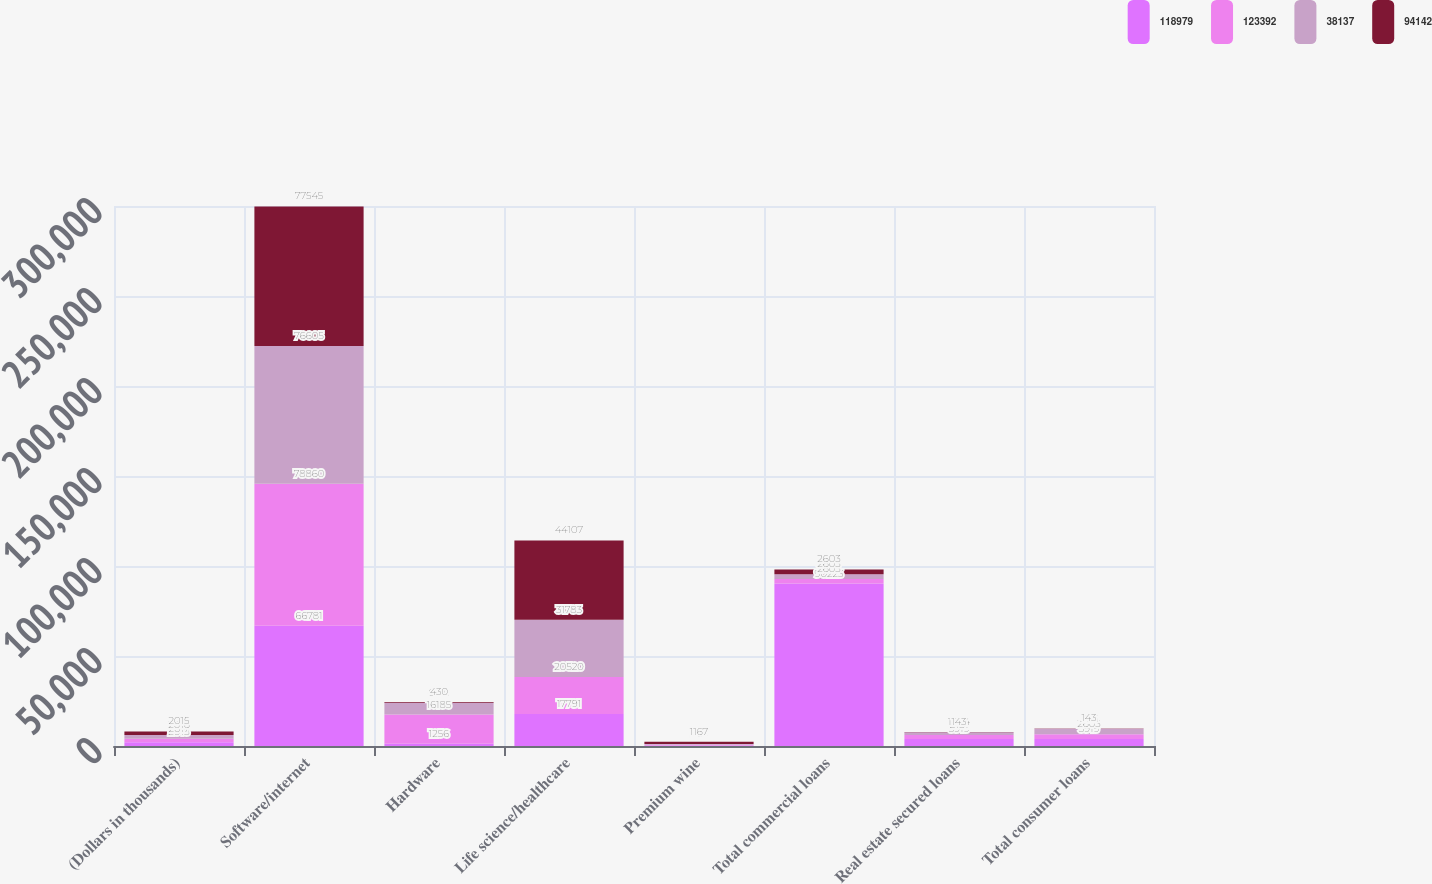Convert chart. <chart><loc_0><loc_0><loc_500><loc_500><stacked_bar_chart><ecel><fcel>(Dollars in thousands)<fcel>Software/internet<fcel>Hardware<fcel>Life science/healthcare<fcel>Premium wine<fcel>Total commercial loans<fcel>Real estate secured loans<fcel>Total consumer loans<nl><fcel>118979<fcel>2018<fcel>66781<fcel>1256<fcel>17791<fcel>284<fcel>90223<fcel>3919<fcel>3919<nl><fcel>123392<fcel>2017<fcel>78860<fcel>16185<fcel>20520<fcel>401<fcel>2603<fcel>2181<fcel>2603<nl><fcel>38137<fcel>2016<fcel>76605<fcel>6581<fcel>31783<fcel>491<fcel>2603<fcel>1504<fcel>3116<nl><fcel>94142<fcel>2015<fcel>77545<fcel>430<fcel>44107<fcel>1167<fcel>2603<fcel>143<fcel>143<nl></chart> 